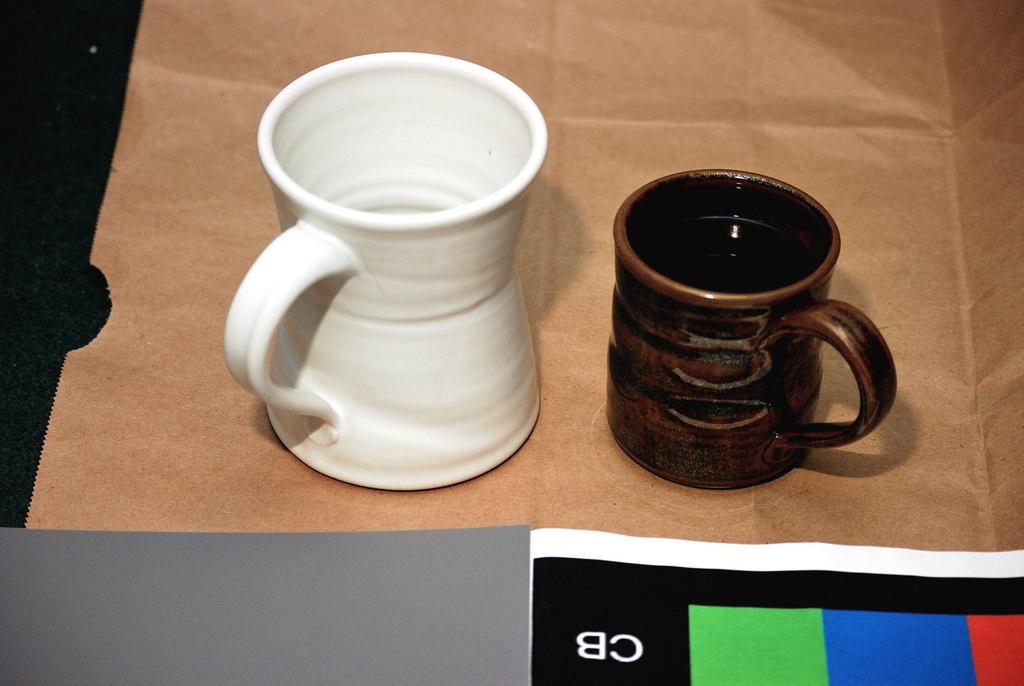What letters are seen?
Make the answer very short. Cb. 